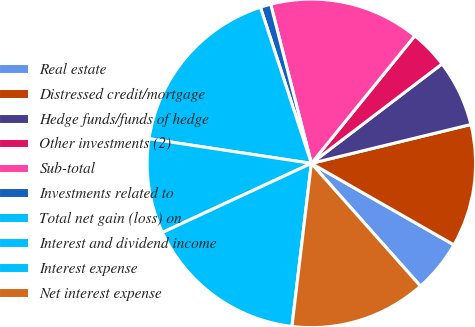<chart> <loc_0><loc_0><loc_500><loc_500><pie_chart><fcel>Real estate<fcel>Distressed credit/mortgage<fcel>Hedge funds/funds of hedge<fcel>Other investments (2)<fcel>Sub-total<fcel>Investments related to<fcel>Total net gain (loss) on<fcel>Interest and dividend income<fcel>Interest expense<fcel>Net interest expense<nl><fcel>5.17%<fcel>12.07%<fcel>6.55%<fcel>3.8%<fcel>14.83%<fcel>1.04%<fcel>17.58%<fcel>9.31%<fcel>16.2%<fcel>13.45%<nl></chart> 